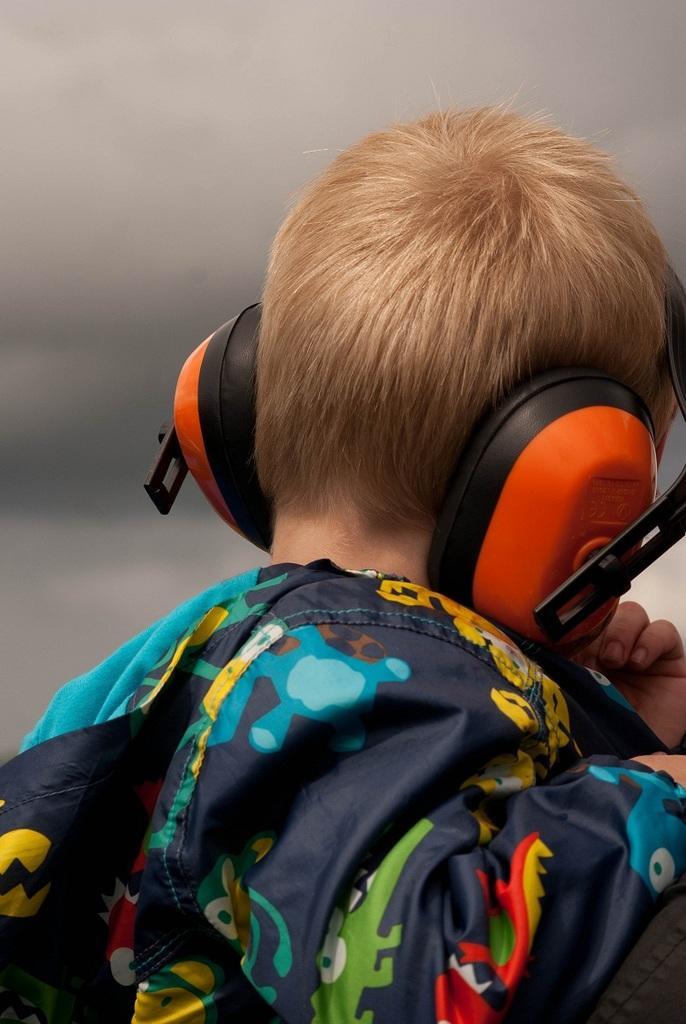Could you give a brief overview of what you see in this image? In this image I can see a boy wearing a headphones and wearing a colorful dress and at the top I can see the sky 